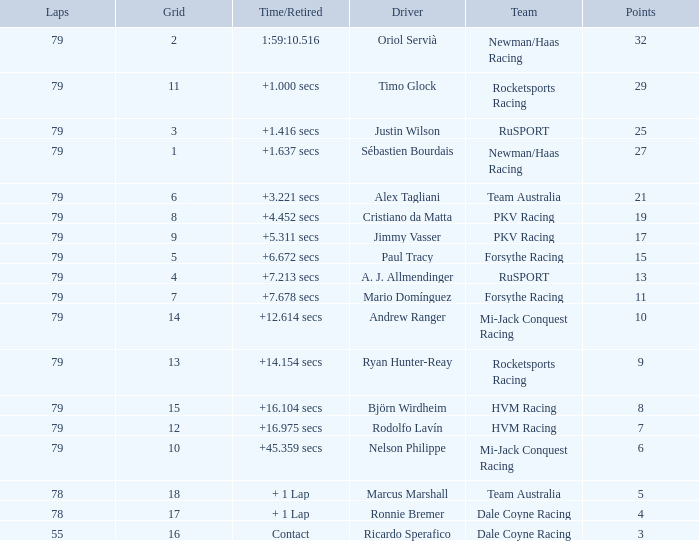Which points has the driver Paul Tracy? 15.0. 